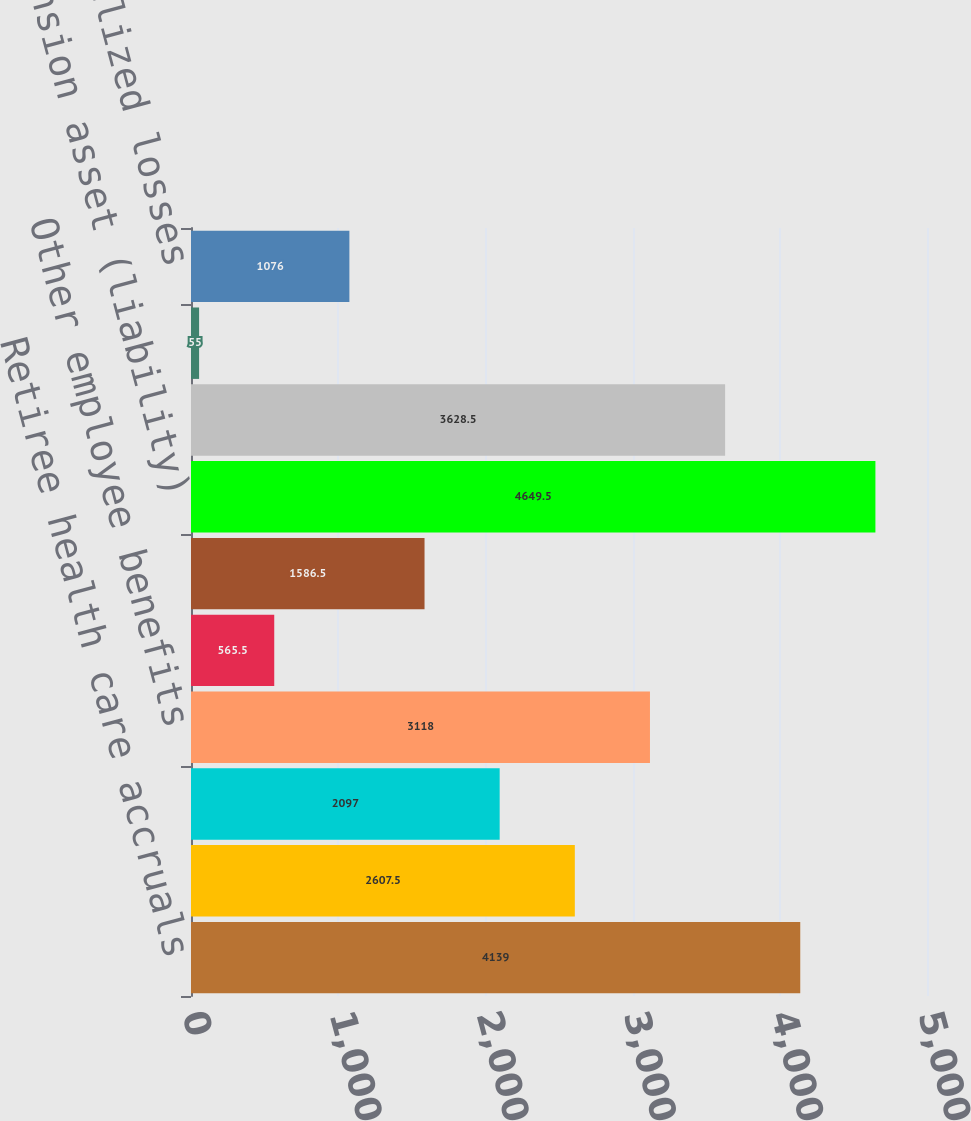Convert chart to OTSL. <chart><loc_0><loc_0><loc_500><loc_500><bar_chart><fcel>Retiree health care accruals<fcel>Inventory and long-term<fcel>Partnerships and joint<fcel>Other employee benefits<fcel>In-process research and<fcel>Net operating loss credit and<fcel>Pension asset (liability)<fcel>Customer and commercial<fcel>Unremitted earnings of non-US<fcel>Other net unrealized losses<nl><fcel>4139<fcel>2607.5<fcel>2097<fcel>3118<fcel>565.5<fcel>1586.5<fcel>4649.5<fcel>3628.5<fcel>55<fcel>1076<nl></chart> 